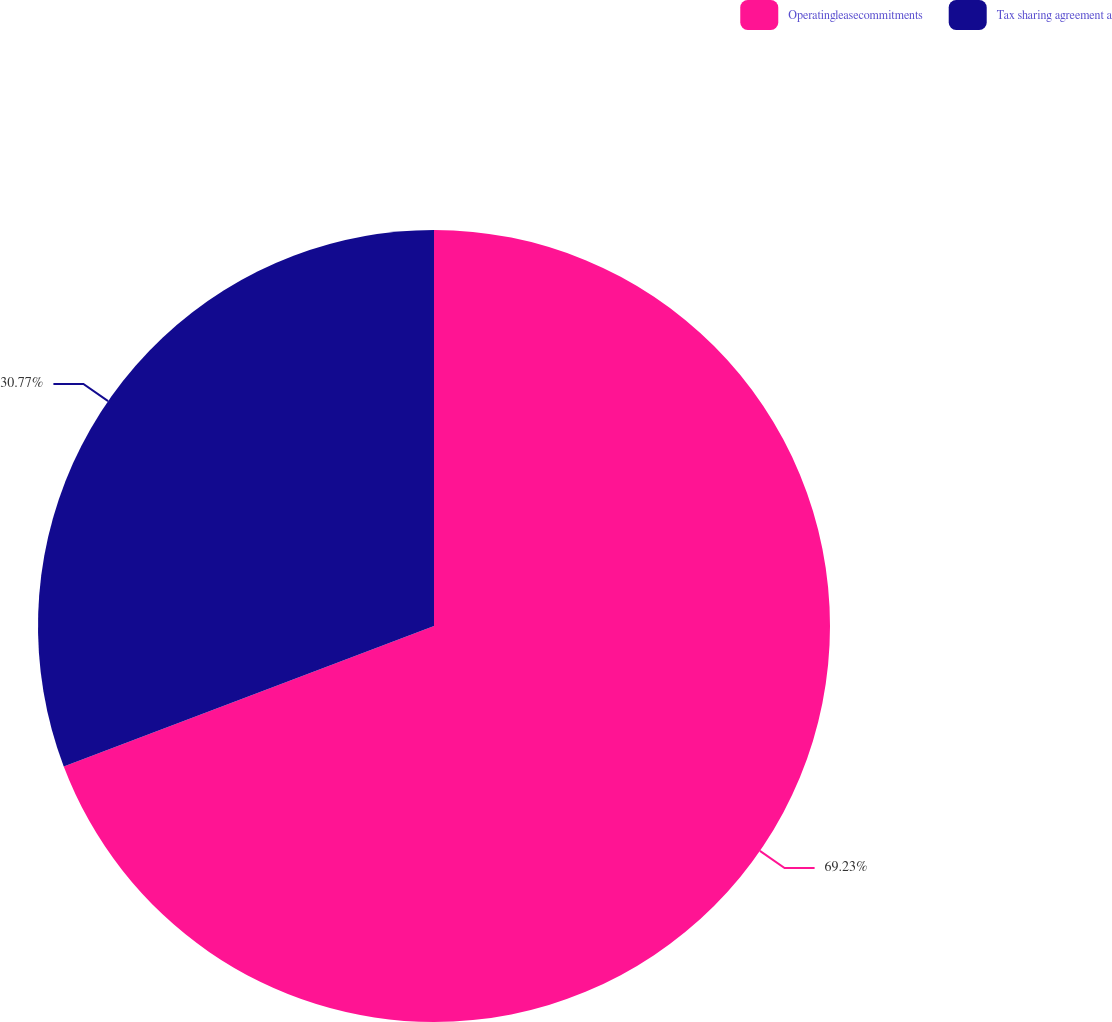<chart> <loc_0><loc_0><loc_500><loc_500><pie_chart><fcel>Operatingleasecommitments<fcel>Tax sharing agreement a<nl><fcel>69.23%<fcel>30.77%<nl></chart> 